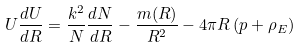<formula> <loc_0><loc_0><loc_500><loc_500>U \frac { d U } { d R } = \frac { k ^ { 2 } } { N } \frac { d N } { d R } - \frac { m ( R ) } { R ^ { 2 } } - 4 \pi R \left ( p + \rho _ { E } \right )</formula> 